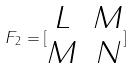<formula> <loc_0><loc_0><loc_500><loc_500>F _ { 2 } = [ \begin{matrix} L & M \\ M & N \end{matrix} ]</formula> 